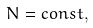<formula> <loc_0><loc_0><loc_500><loc_500>N = c o n s t ,</formula> 